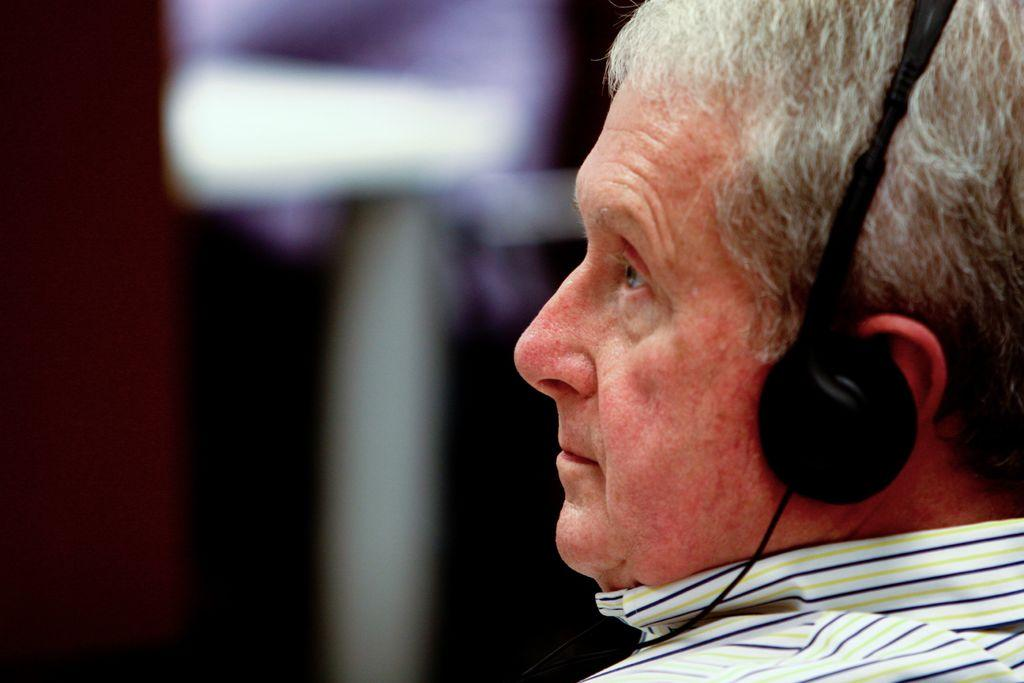What is the main subject of the image? The main subject of the image is a man. What is the man wearing in the image? The man is wearing a headset in the image. Can you describe the background of the man? The background of the man is blurred in the image. What type of soda is the man attempting to drink in the image? There is no soda present in the image, and the man is not attempting to drink anything. What is the man's mindset while wearing the headset in the image? The image does not provide any information about the man's mindset or thoughts while wearing the headset. 